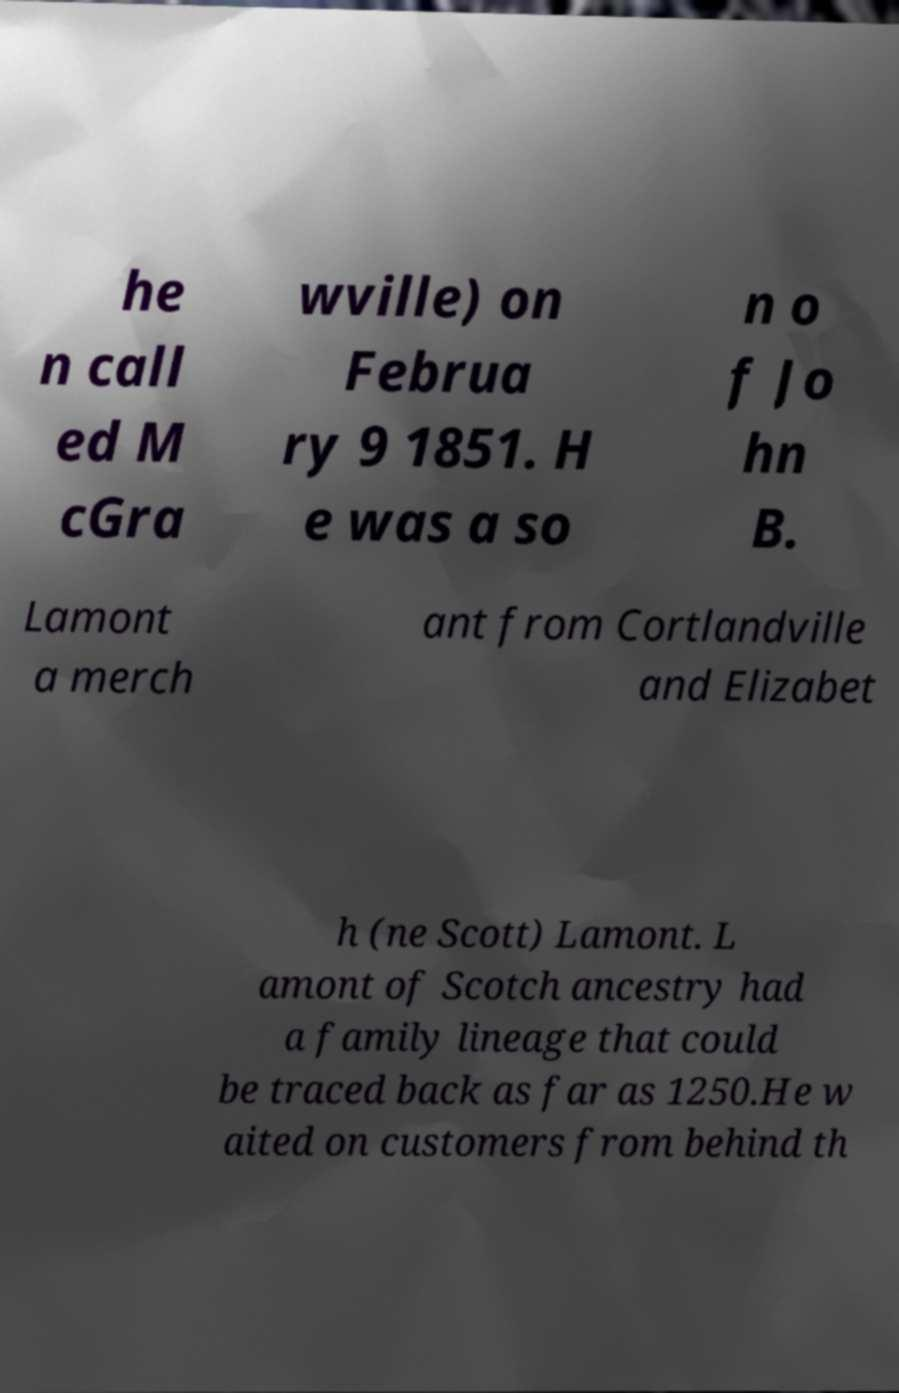Could you extract and type out the text from this image? he n call ed M cGra wville) on Februa ry 9 1851. H e was a so n o f Jo hn B. Lamont a merch ant from Cortlandville and Elizabet h (ne Scott) Lamont. L amont of Scotch ancestry had a family lineage that could be traced back as far as 1250.He w aited on customers from behind th 